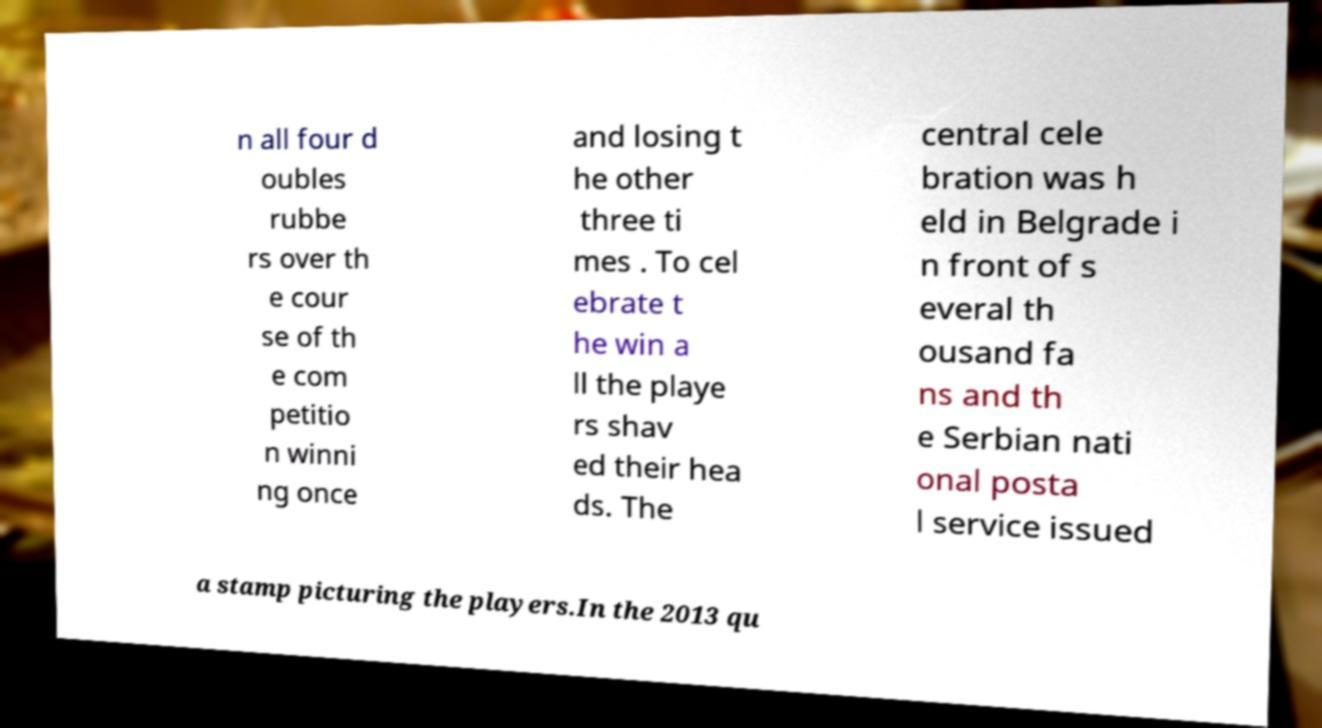I need the written content from this picture converted into text. Can you do that? n all four d oubles rubbe rs over th e cour se of th e com petitio n winni ng once and losing t he other three ti mes . To cel ebrate t he win a ll the playe rs shav ed their hea ds. The central cele bration was h eld in Belgrade i n front of s everal th ousand fa ns and th e Serbian nati onal posta l service issued a stamp picturing the players.In the 2013 qu 